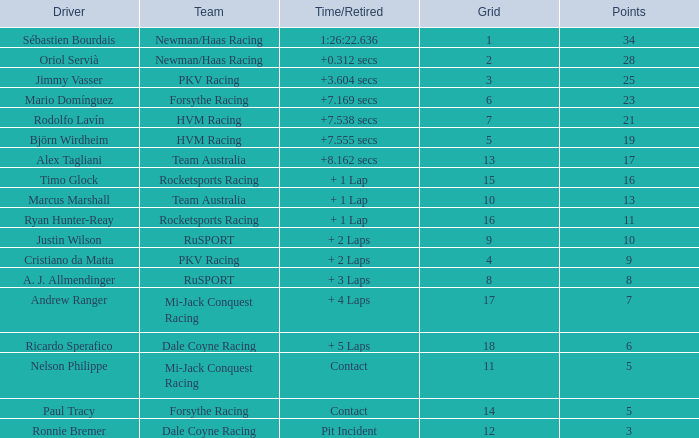What is the maximum points when the grid is smaller than 13 and the time/retired is + 21.0. 